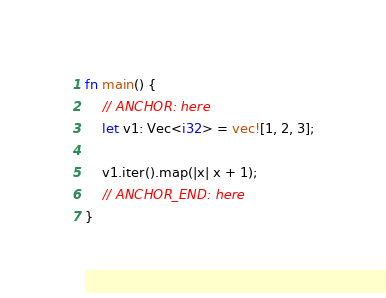<code> <loc_0><loc_0><loc_500><loc_500><_Rust_>fn main() {
    // ANCHOR: here
    let v1: Vec<i32> = vec![1, 2, 3];

    v1.iter().map(|x| x + 1);
    // ANCHOR_END: here
}
</code> 